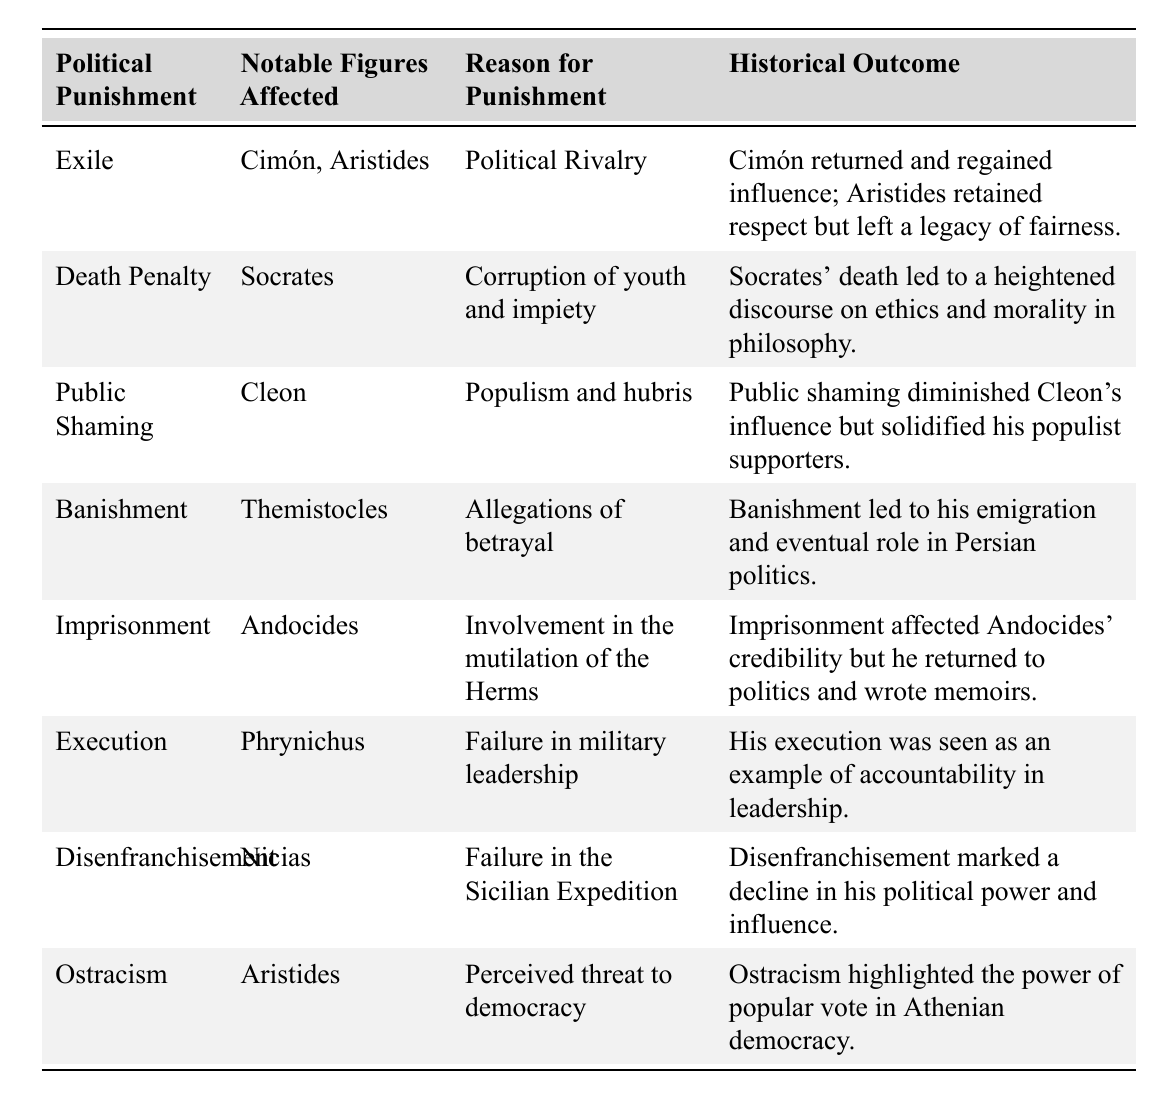What political punishment was associated with Socrates? The table lists the political punishment for Socrates as the "Death Penalty."
Answer: Death Penalty Which notable figures were affected by exile? According to the table, the notable figures affected by exile are Cimón and Aristides.
Answer: Cimón, Aristides What was the reason for Cleon's public shaming? The table specifies that Cleon was publicly shamed due to "Populism and hubris."
Answer: Populism and hubris Which historical outcome resulted from the execution of Phrynichus? The table indicates that Phrynichus' execution was viewed as an example of accountability in leadership.
Answer: Accountability in leadership How many notable figures were affected by imprisonment? The table shows that only one notable figure, Andocides, was affected by imprisonment.
Answer: 1 Did Nicias face ostracism as a political punishment? The table indicates that Nicias was punished through "Disenfranchisement," not ostracism.
Answer: No Which political punishment led to the emigration of Themistocles? The punishment that led to Themistocles' emigration was "Banishment," as noted in the table.
Answer: Banishment What is the common theme of the reasons for political punishments affecting notable figures? The common theme identifies political rivalry, failure, and allegations as reasons listed for the punishments, suggesting a focus on political integrity.
Answer: Political integrity How did the outcome of the death penalty for Socrates influence philosophical discourse? The table indicates that Socrates' death heightened discourse on ethics and morality, showcasing his philosophical impact.
Answer: Heightened discourse on ethics If a figure experienced public shaming, what was the effect on their influence? According to the table, public shaming diminished Cleon's influence but solidified his populist supporters, suggesting a dual effect on political capital.
Answer: Diminished influence, increased support What were the implications of the ostracism of Aristides on Athenian democracy? The table notes that ostracism highlighted the power of popular vote in Athenian democracy, implying a significant impact on democratic processes.
Answer: Highlighted popular vote power 